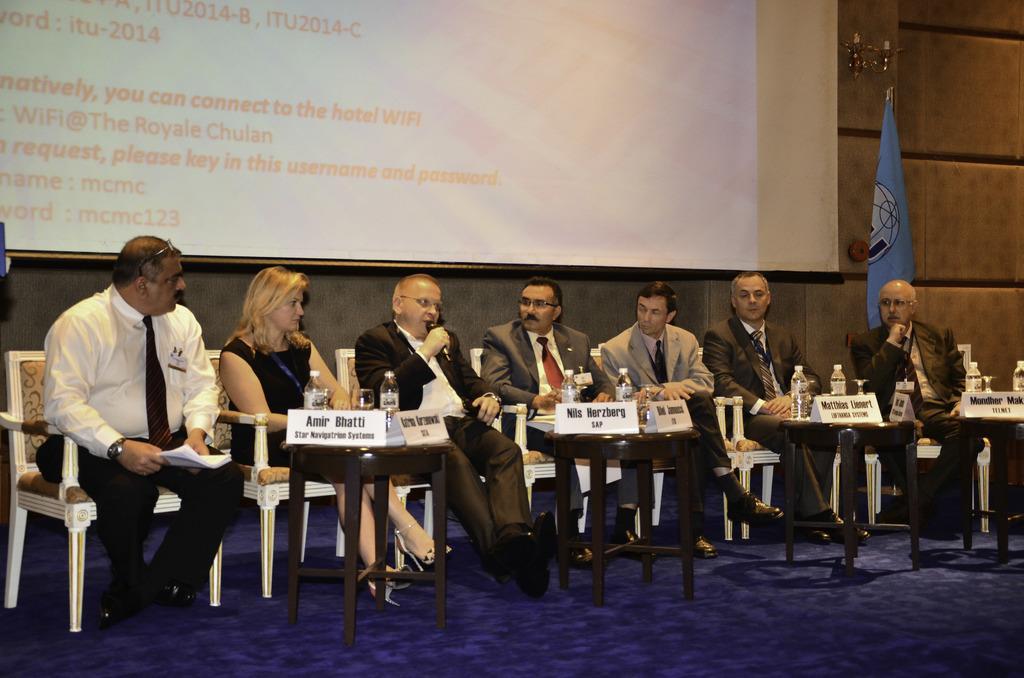In one or two sentences, can you explain what this image depicts? In this picture there are group of people those who are sitting on a stage in a row, and there is a projector screen at the center of the image, it seems to be an argument which they are conducting on the stage. 